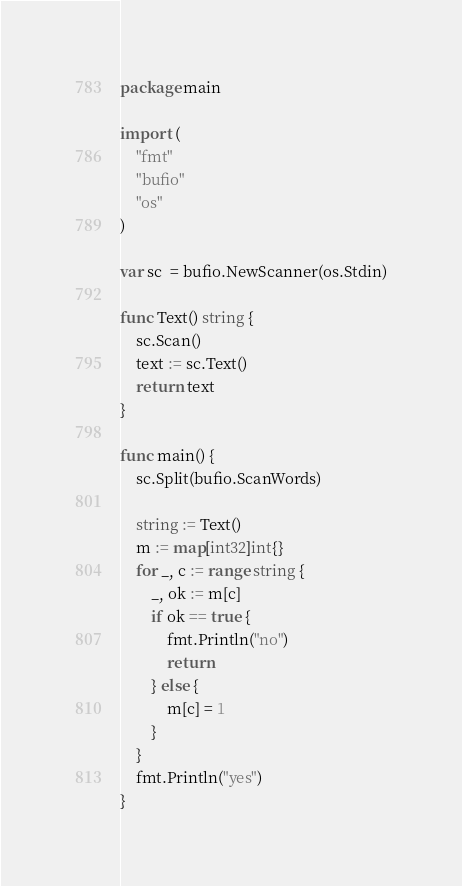Convert code to text. <code><loc_0><loc_0><loc_500><loc_500><_Go_>package main

import (
	"fmt"
	"bufio"
	"os"
)

var sc  = bufio.NewScanner(os.Stdin)

func Text() string {
	sc.Scan()
	text := sc.Text()
	return text
}

func main() {
	sc.Split(bufio.ScanWords)

	string := Text()
	m := map[int32]int{}
	for _, c := range string {
		_, ok := m[c]
		if ok == true {
			fmt.Println("no")
			return
		} else {
			m[c] = 1
		}
	}
	fmt.Println("yes")
}
</code> 